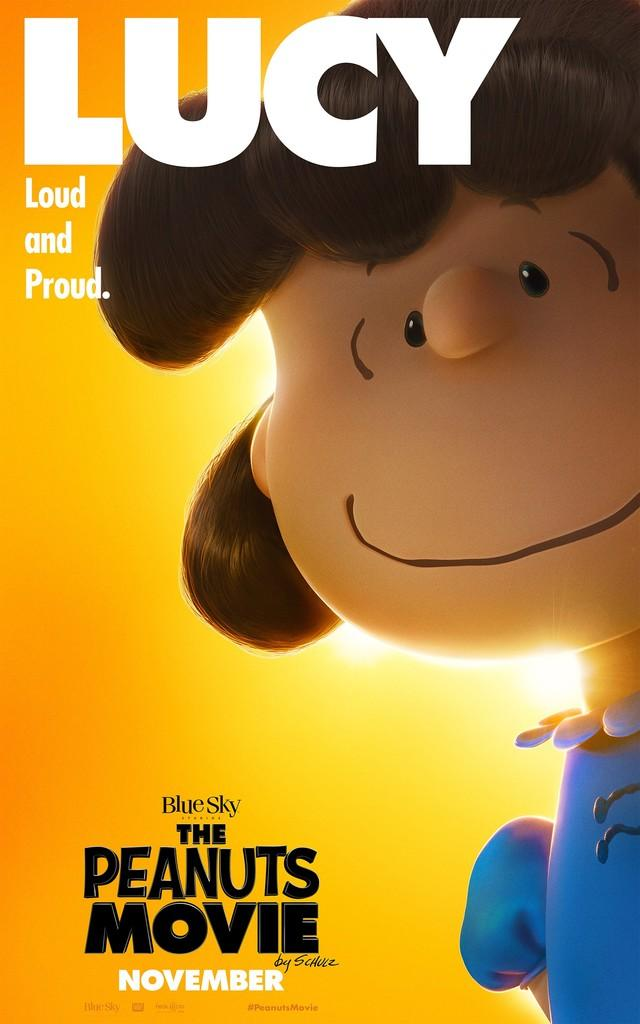<image>
Provide a brief description of the given image. A movie poster for The Peanuts Movie advertising it is released in November 